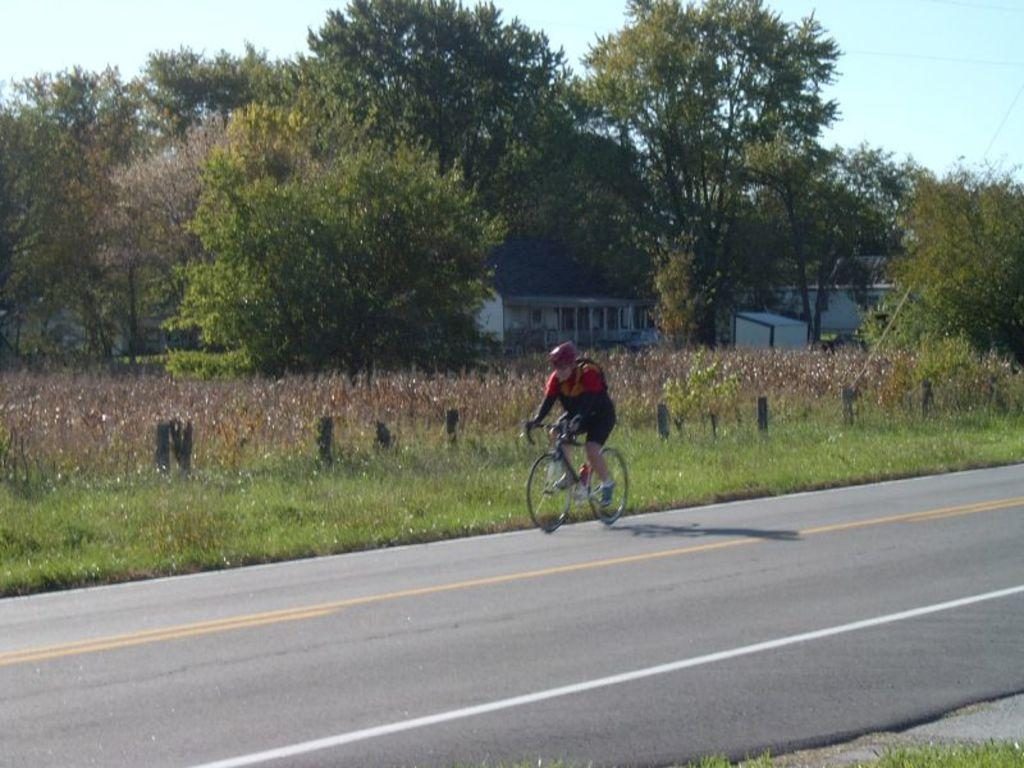What is the main subject of the image? There is a person riding a bicycle on the road. What can be seen in the background of the image? There are trees, plants, grass, buildings, windows, and the sky visible in the background. Can you tell me how many grapes are hanging from the bicycle in the image? There are no grapes present in the image; the main subject is a person riding a bicycle on the road. What type of bell can be heard ringing in the image? There is no bell present or audible in the image. 